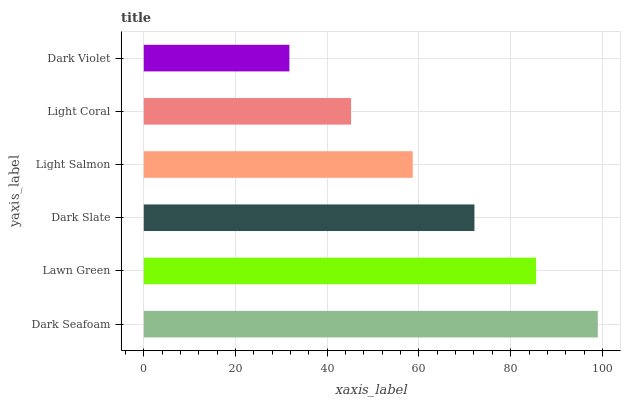Is Dark Violet the minimum?
Answer yes or no. Yes. Is Dark Seafoam the maximum?
Answer yes or no. Yes. Is Lawn Green the minimum?
Answer yes or no. No. Is Lawn Green the maximum?
Answer yes or no. No. Is Dark Seafoam greater than Lawn Green?
Answer yes or no. Yes. Is Lawn Green less than Dark Seafoam?
Answer yes or no. Yes. Is Lawn Green greater than Dark Seafoam?
Answer yes or no. No. Is Dark Seafoam less than Lawn Green?
Answer yes or no. No. Is Dark Slate the high median?
Answer yes or no. Yes. Is Light Salmon the low median?
Answer yes or no. Yes. Is Lawn Green the high median?
Answer yes or no. No. Is Dark Seafoam the low median?
Answer yes or no. No. 